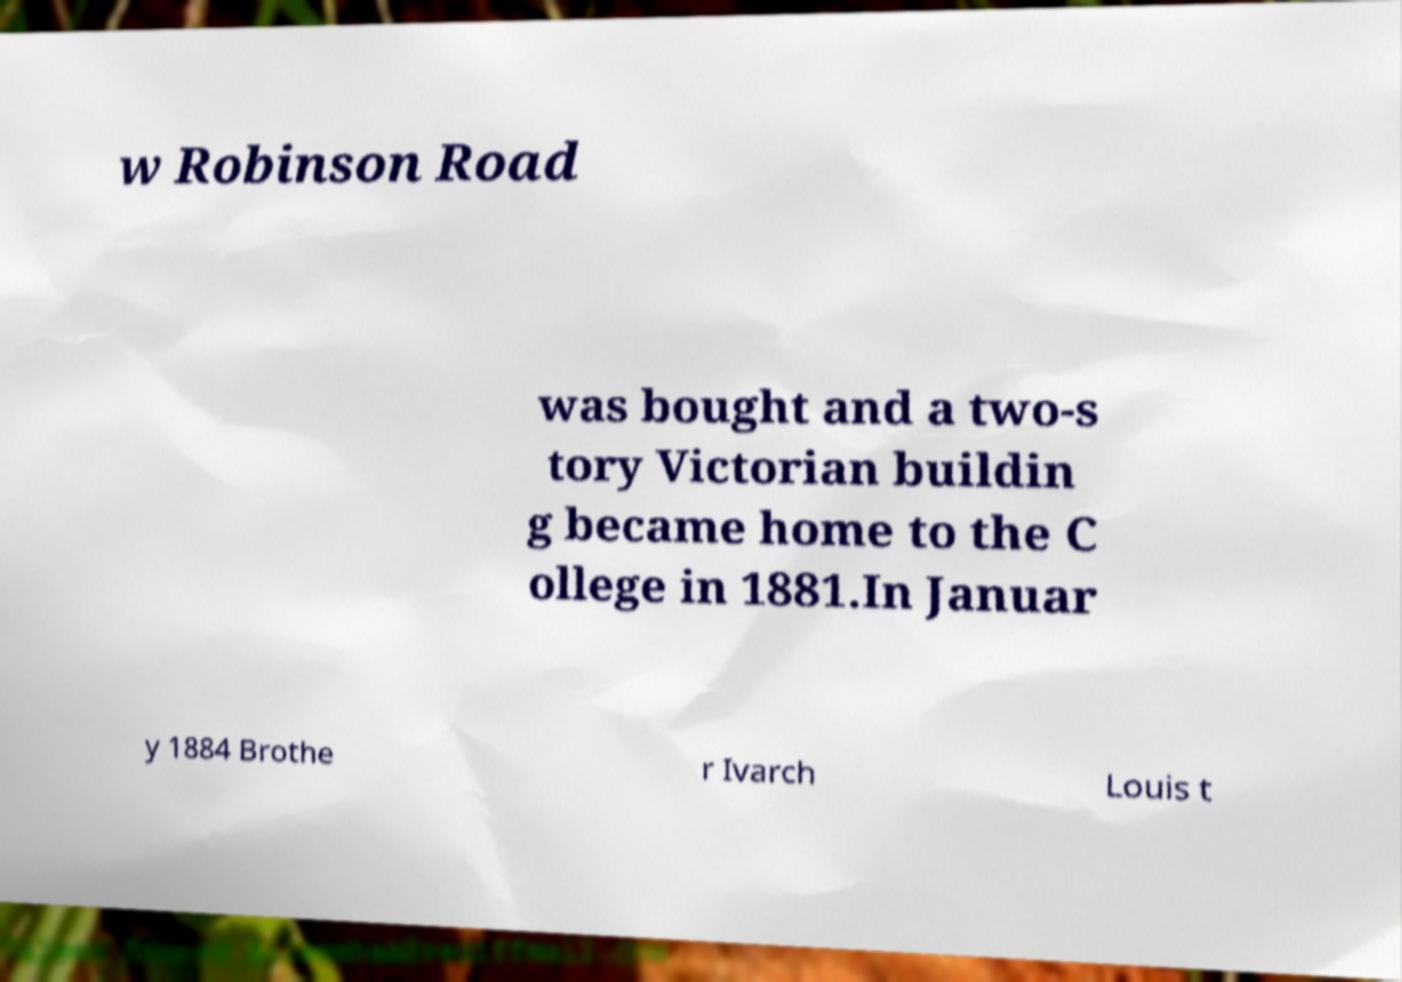What messages or text are displayed in this image? I need them in a readable, typed format. w Robinson Road was bought and a two-s tory Victorian buildin g became home to the C ollege in 1881.In Januar y 1884 Brothe r Ivarch Louis t 